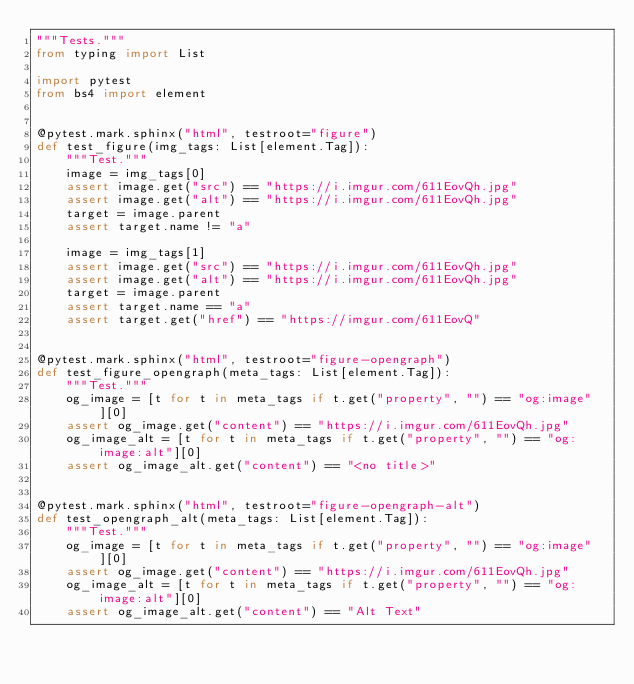Convert code to text. <code><loc_0><loc_0><loc_500><loc_500><_Python_>"""Tests."""
from typing import List

import pytest
from bs4 import element


@pytest.mark.sphinx("html", testroot="figure")
def test_figure(img_tags: List[element.Tag]):
    """Test."""
    image = img_tags[0]
    assert image.get("src") == "https://i.imgur.com/611EovQh.jpg"
    assert image.get("alt") == "https://i.imgur.com/611EovQh.jpg"
    target = image.parent
    assert target.name != "a"

    image = img_tags[1]
    assert image.get("src") == "https://i.imgur.com/611EovQh.jpg"
    assert image.get("alt") == "https://i.imgur.com/611EovQh.jpg"
    target = image.parent
    assert target.name == "a"
    assert target.get("href") == "https://imgur.com/611EovQ"


@pytest.mark.sphinx("html", testroot="figure-opengraph")
def test_figure_opengraph(meta_tags: List[element.Tag]):
    """Test."""
    og_image = [t for t in meta_tags if t.get("property", "") == "og:image"][0]
    assert og_image.get("content") == "https://i.imgur.com/611EovQh.jpg"
    og_image_alt = [t for t in meta_tags if t.get("property", "") == "og:image:alt"][0]
    assert og_image_alt.get("content") == "<no title>"


@pytest.mark.sphinx("html", testroot="figure-opengraph-alt")
def test_opengraph_alt(meta_tags: List[element.Tag]):
    """Test."""
    og_image = [t for t in meta_tags if t.get("property", "") == "og:image"][0]
    assert og_image.get("content") == "https://i.imgur.com/611EovQh.jpg"
    og_image_alt = [t for t in meta_tags if t.get("property", "") == "og:image:alt"][0]
    assert og_image_alt.get("content") == "Alt Text"
</code> 